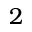Convert formula to latex. <formula><loc_0><loc_0><loc_500><loc_500>2</formula> 